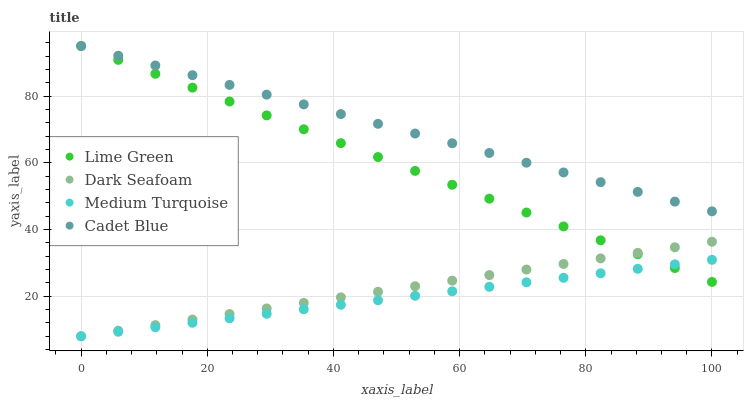Does Medium Turquoise have the minimum area under the curve?
Answer yes or no. Yes. Does Cadet Blue have the maximum area under the curve?
Answer yes or no. Yes. Does Lime Green have the minimum area under the curve?
Answer yes or no. No. Does Lime Green have the maximum area under the curve?
Answer yes or no. No. Is Medium Turquoise the smoothest?
Answer yes or no. Yes. Is Lime Green the roughest?
Answer yes or no. Yes. Is Cadet Blue the smoothest?
Answer yes or no. No. Is Cadet Blue the roughest?
Answer yes or no. No. Does Dark Seafoam have the lowest value?
Answer yes or no. Yes. Does Lime Green have the lowest value?
Answer yes or no. No. Does Lime Green have the highest value?
Answer yes or no. Yes. Does Medium Turquoise have the highest value?
Answer yes or no. No. Is Dark Seafoam less than Cadet Blue?
Answer yes or no. Yes. Is Cadet Blue greater than Dark Seafoam?
Answer yes or no. Yes. Does Lime Green intersect Cadet Blue?
Answer yes or no. Yes. Is Lime Green less than Cadet Blue?
Answer yes or no. No. Is Lime Green greater than Cadet Blue?
Answer yes or no. No. Does Dark Seafoam intersect Cadet Blue?
Answer yes or no. No. 